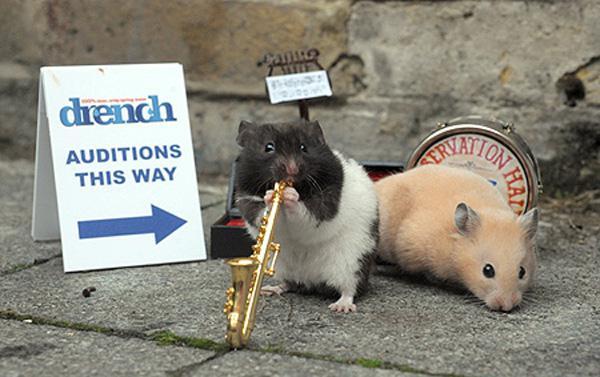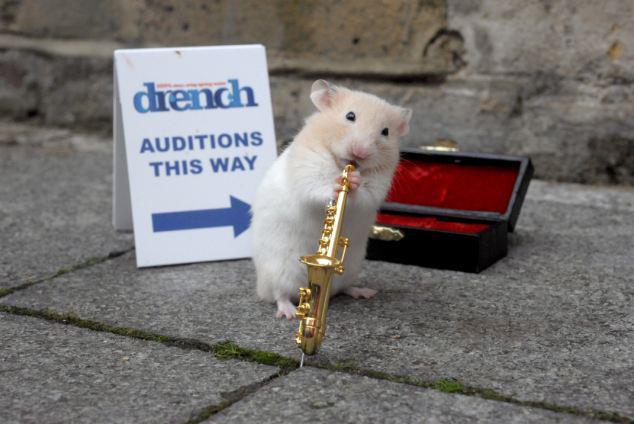The first image is the image on the left, the second image is the image on the right. Assess this claim about the two images: "Little animals are shown with tiny musical instruments and an audition sign.". Correct or not? Answer yes or no. Yes. The first image is the image on the left, the second image is the image on the right. Considering the images on both sides, is "There are only two mice and they are both wearing something on their heads." valid? Answer yes or no. No. 